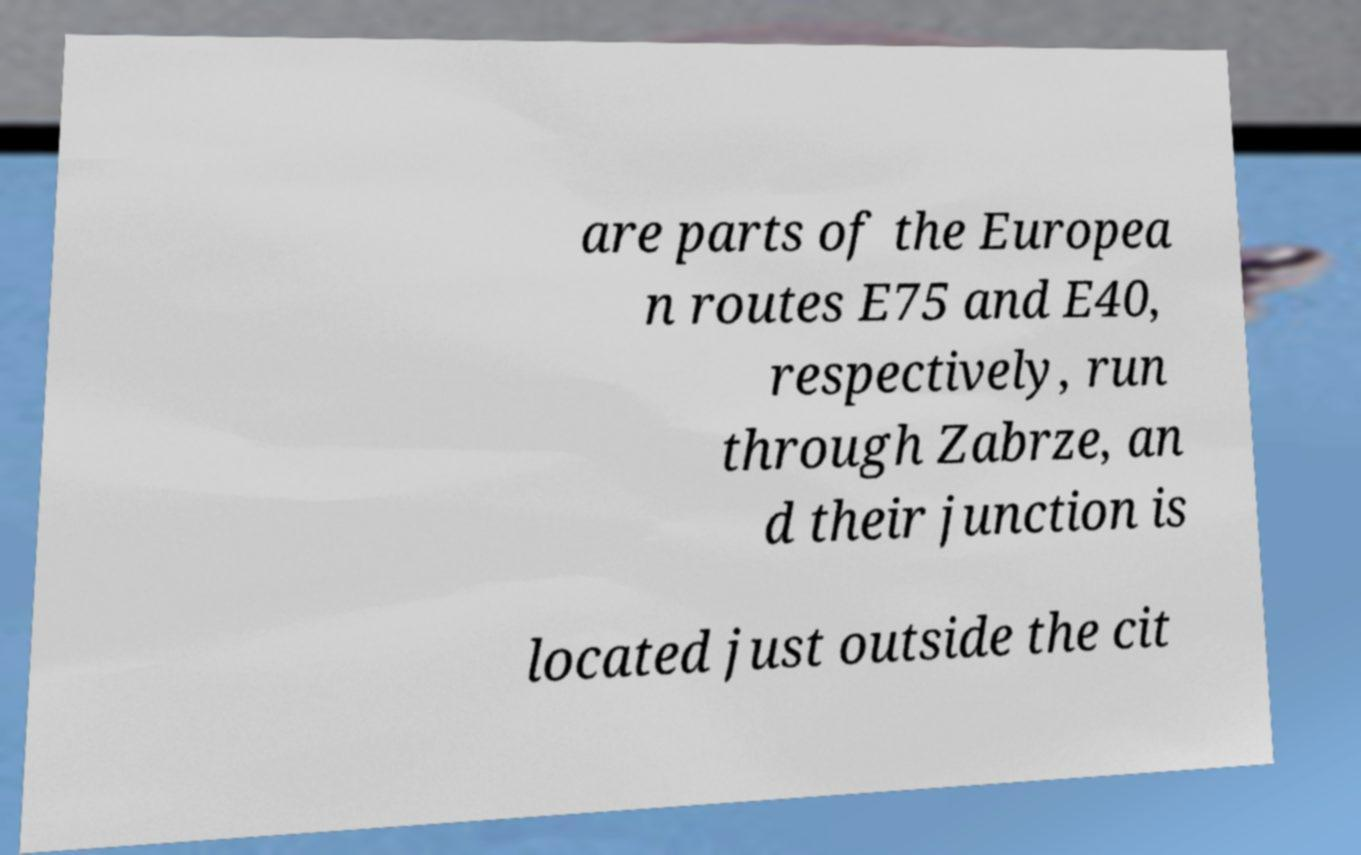Can you accurately transcribe the text from the provided image for me? are parts of the Europea n routes E75 and E40, respectively, run through Zabrze, an d their junction is located just outside the cit 